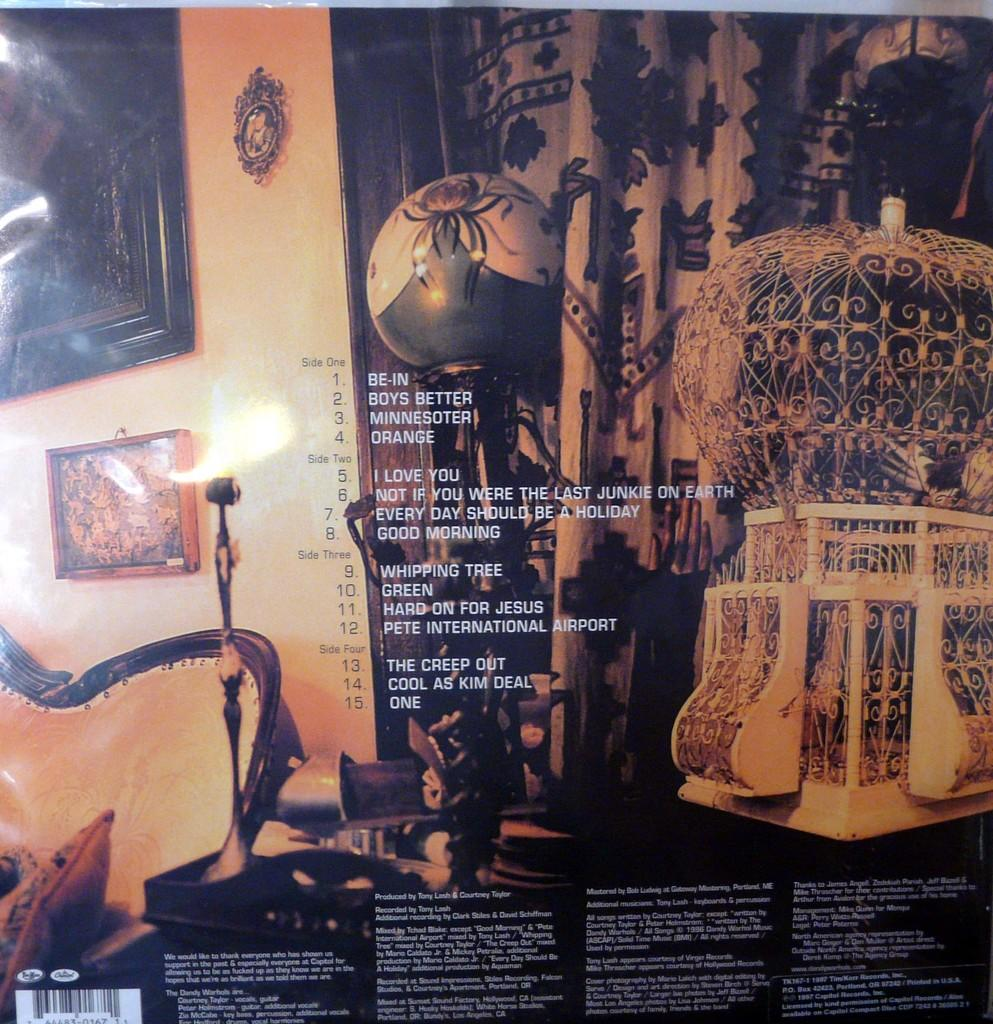<image>
Share a concise interpretation of the image provided. The back of an album cover with the first song called Be-In. 